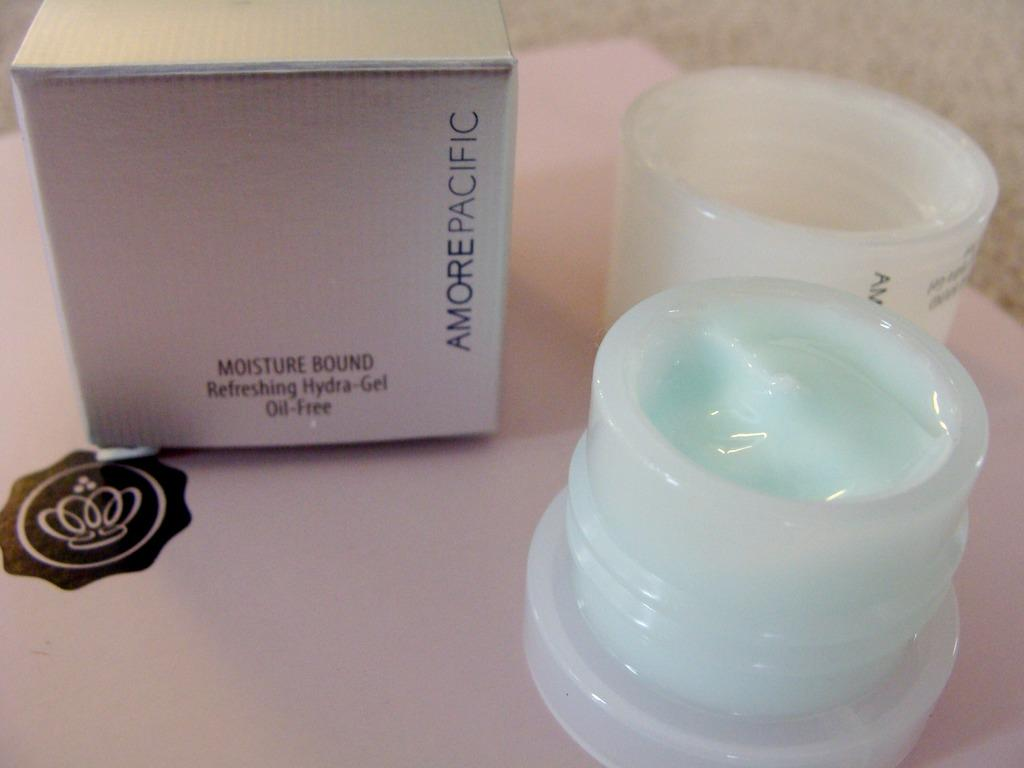<image>
Present a compact description of the photo's key features. An opened cosmetic item is on a table next to its box which says that it is oil free. 